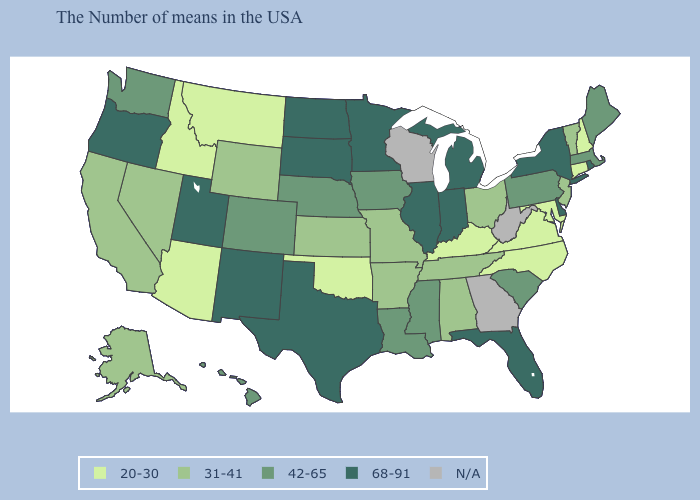Name the states that have a value in the range 31-41?
Answer briefly. Vermont, New Jersey, Ohio, Alabama, Tennessee, Missouri, Arkansas, Kansas, Wyoming, Nevada, California, Alaska. Among the states that border Idaho , does Montana have the lowest value?
Write a very short answer. Yes. Name the states that have a value in the range N/A?
Quick response, please. West Virginia, Georgia, Wisconsin. Which states hav the highest value in the South?
Quick response, please. Delaware, Florida, Texas. Which states hav the highest value in the Northeast?
Concise answer only. Rhode Island, New York. How many symbols are there in the legend?
Concise answer only. 5. Name the states that have a value in the range 20-30?
Quick response, please. New Hampshire, Connecticut, Maryland, Virginia, North Carolina, Kentucky, Oklahoma, Montana, Arizona, Idaho. Name the states that have a value in the range 68-91?
Give a very brief answer. Rhode Island, New York, Delaware, Florida, Michigan, Indiana, Illinois, Minnesota, Texas, South Dakota, North Dakota, New Mexico, Utah, Oregon. Does Arizona have the lowest value in the USA?
Short answer required. Yes. What is the value of Hawaii?
Be succinct. 42-65. Name the states that have a value in the range 31-41?
Quick response, please. Vermont, New Jersey, Ohio, Alabama, Tennessee, Missouri, Arkansas, Kansas, Wyoming, Nevada, California, Alaska. Name the states that have a value in the range 31-41?
Quick response, please. Vermont, New Jersey, Ohio, Alabama, Tennessee, Missouri, Arkansas, Kansas, Wyoming, Nevada, California, Alaska. Which states hav the highest value in the West?
Answer briefly. New Mexico, Utah, Oregon. How many symbols are there in the legend?
Keep it brief. 5. 